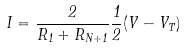<formula> <loc_0><loc_0><loc_500><loc_500>I = \frac { 2 } { R _ { 1 } + R _ { N + 1 } } \frac { 1 } { 2 } ( V - V _ { T } )</formula> 